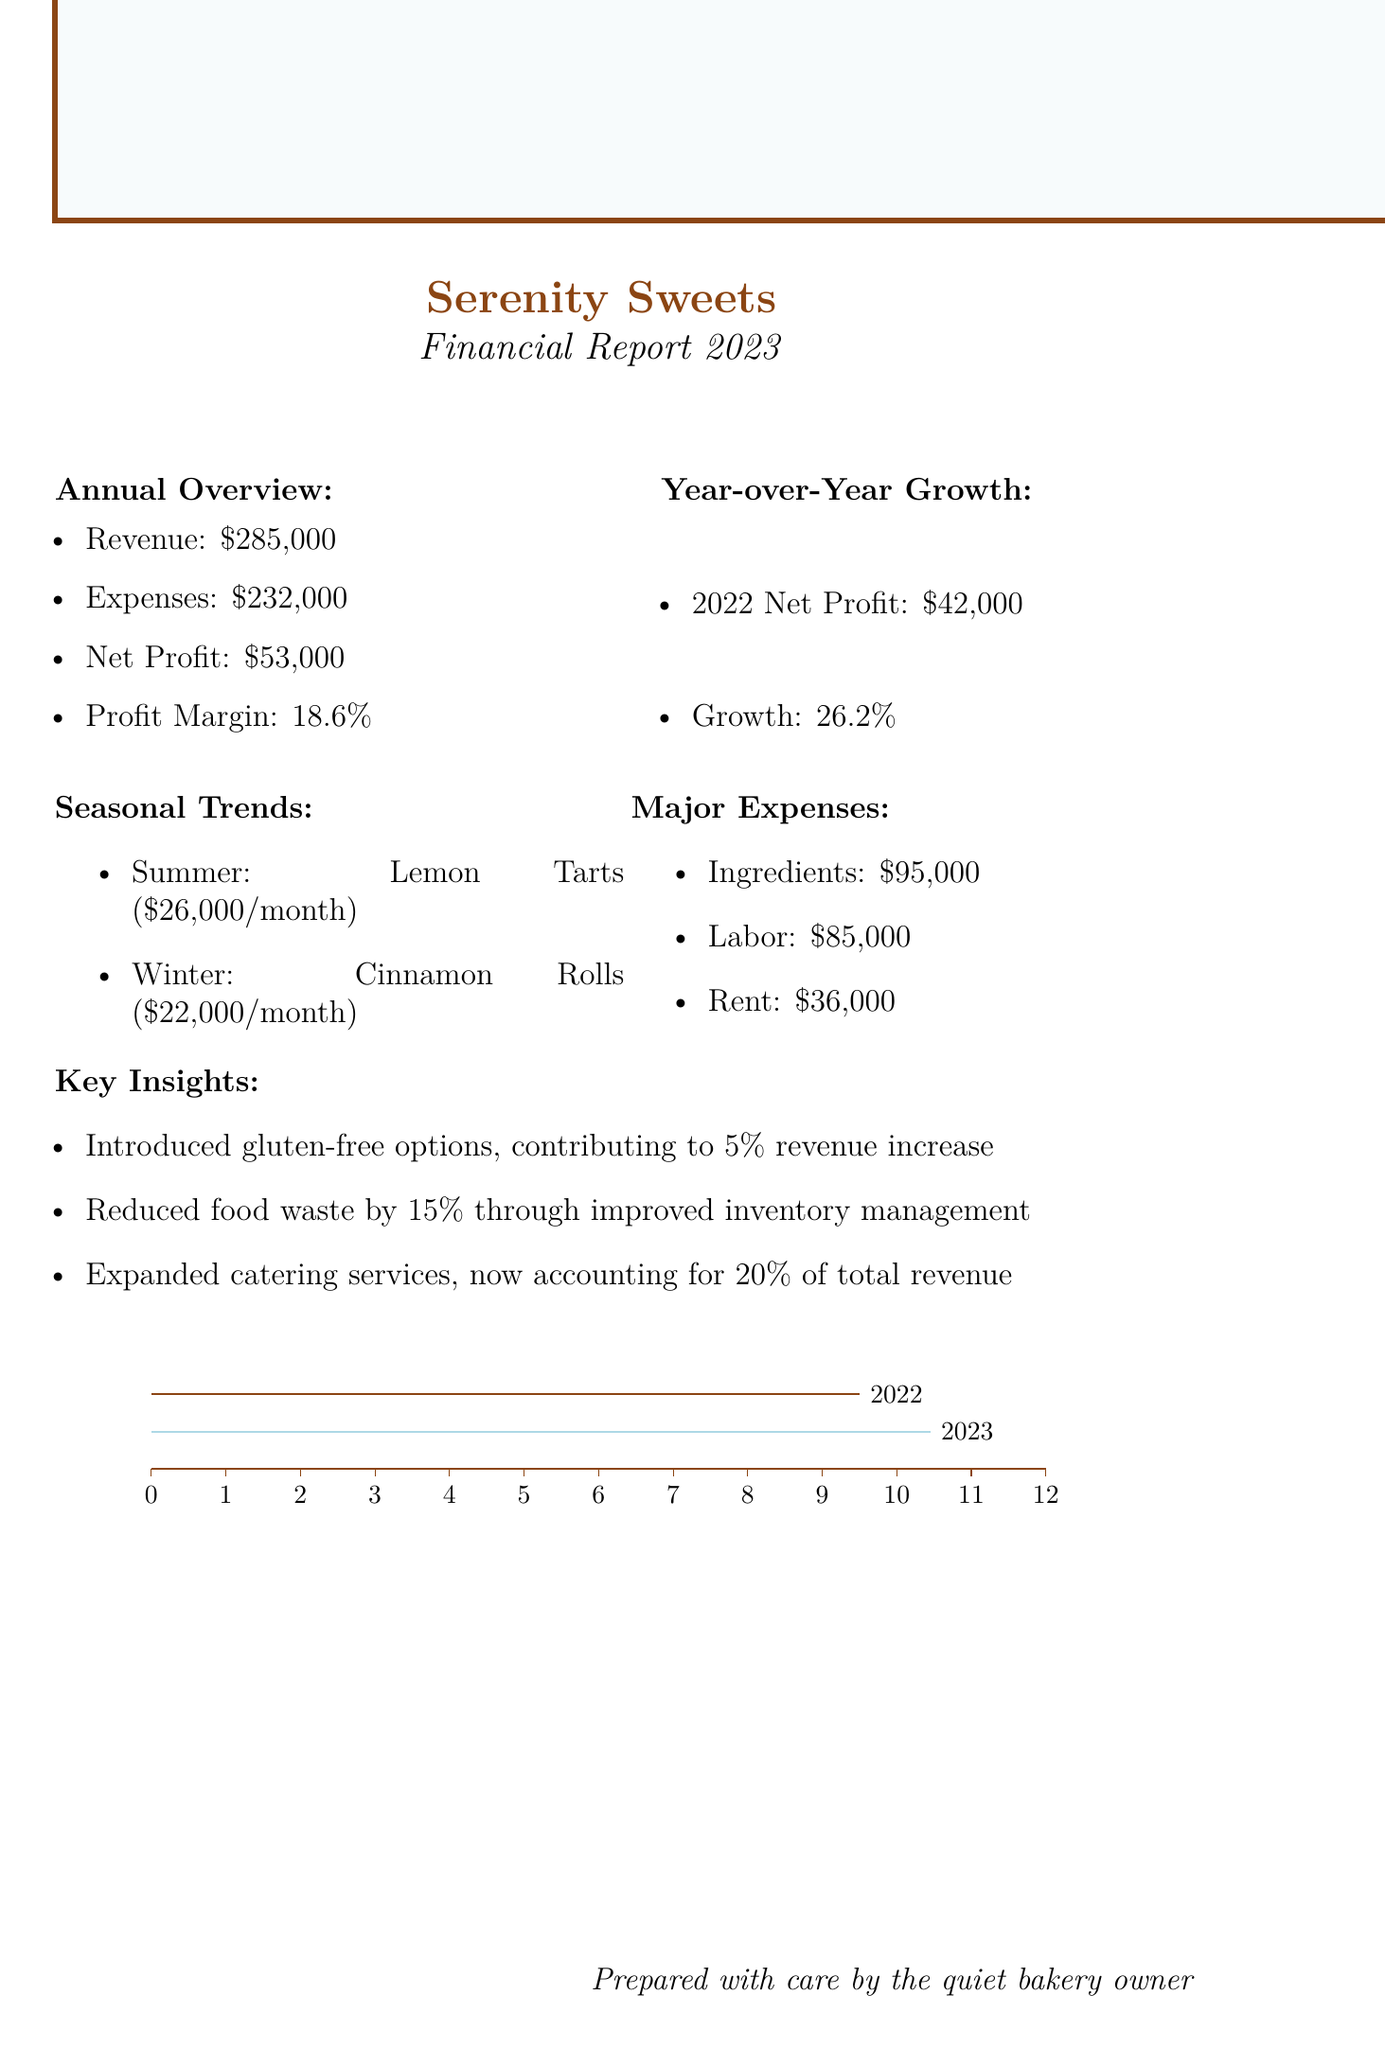What is the bakery's name? The bakery's name is mentioned at the top of the document.
Answer: Serenity Sweets What was the net profit for 2023? The net profit for the current financial year is listed in the annual overview section.
Answer: $53,000 What was the revenue in 2022? The revenue from the previous year is provided under the year-over-year growth section.
Answer: $260,000 What was the top-selling item in summer? The seasonal trends section specifies the top-selling item for each season.
Answer: Lemon Tarts What was the year-over-year growth percentage? This information can be found in the year-over-year growth section, comparing 2023 to 2022.
Answer: 26.2% What is the average monthly revenue in winter? The average monthly revenue for winter is detailed in the seasonal trends section.
Answer: $22,000 What are the major expenses related to ingredients? The major expenses section provides a breakdown of expenses by category.
Answer: $95,000 Which category of expenses had the highest amount? This question requires comparing the amounts listed in the major expenses section.
Answer: Ingredients What percentage of total revenue does expanded catering services now account for? This insight is mentioned in the key insights section.
Answer: 20% 